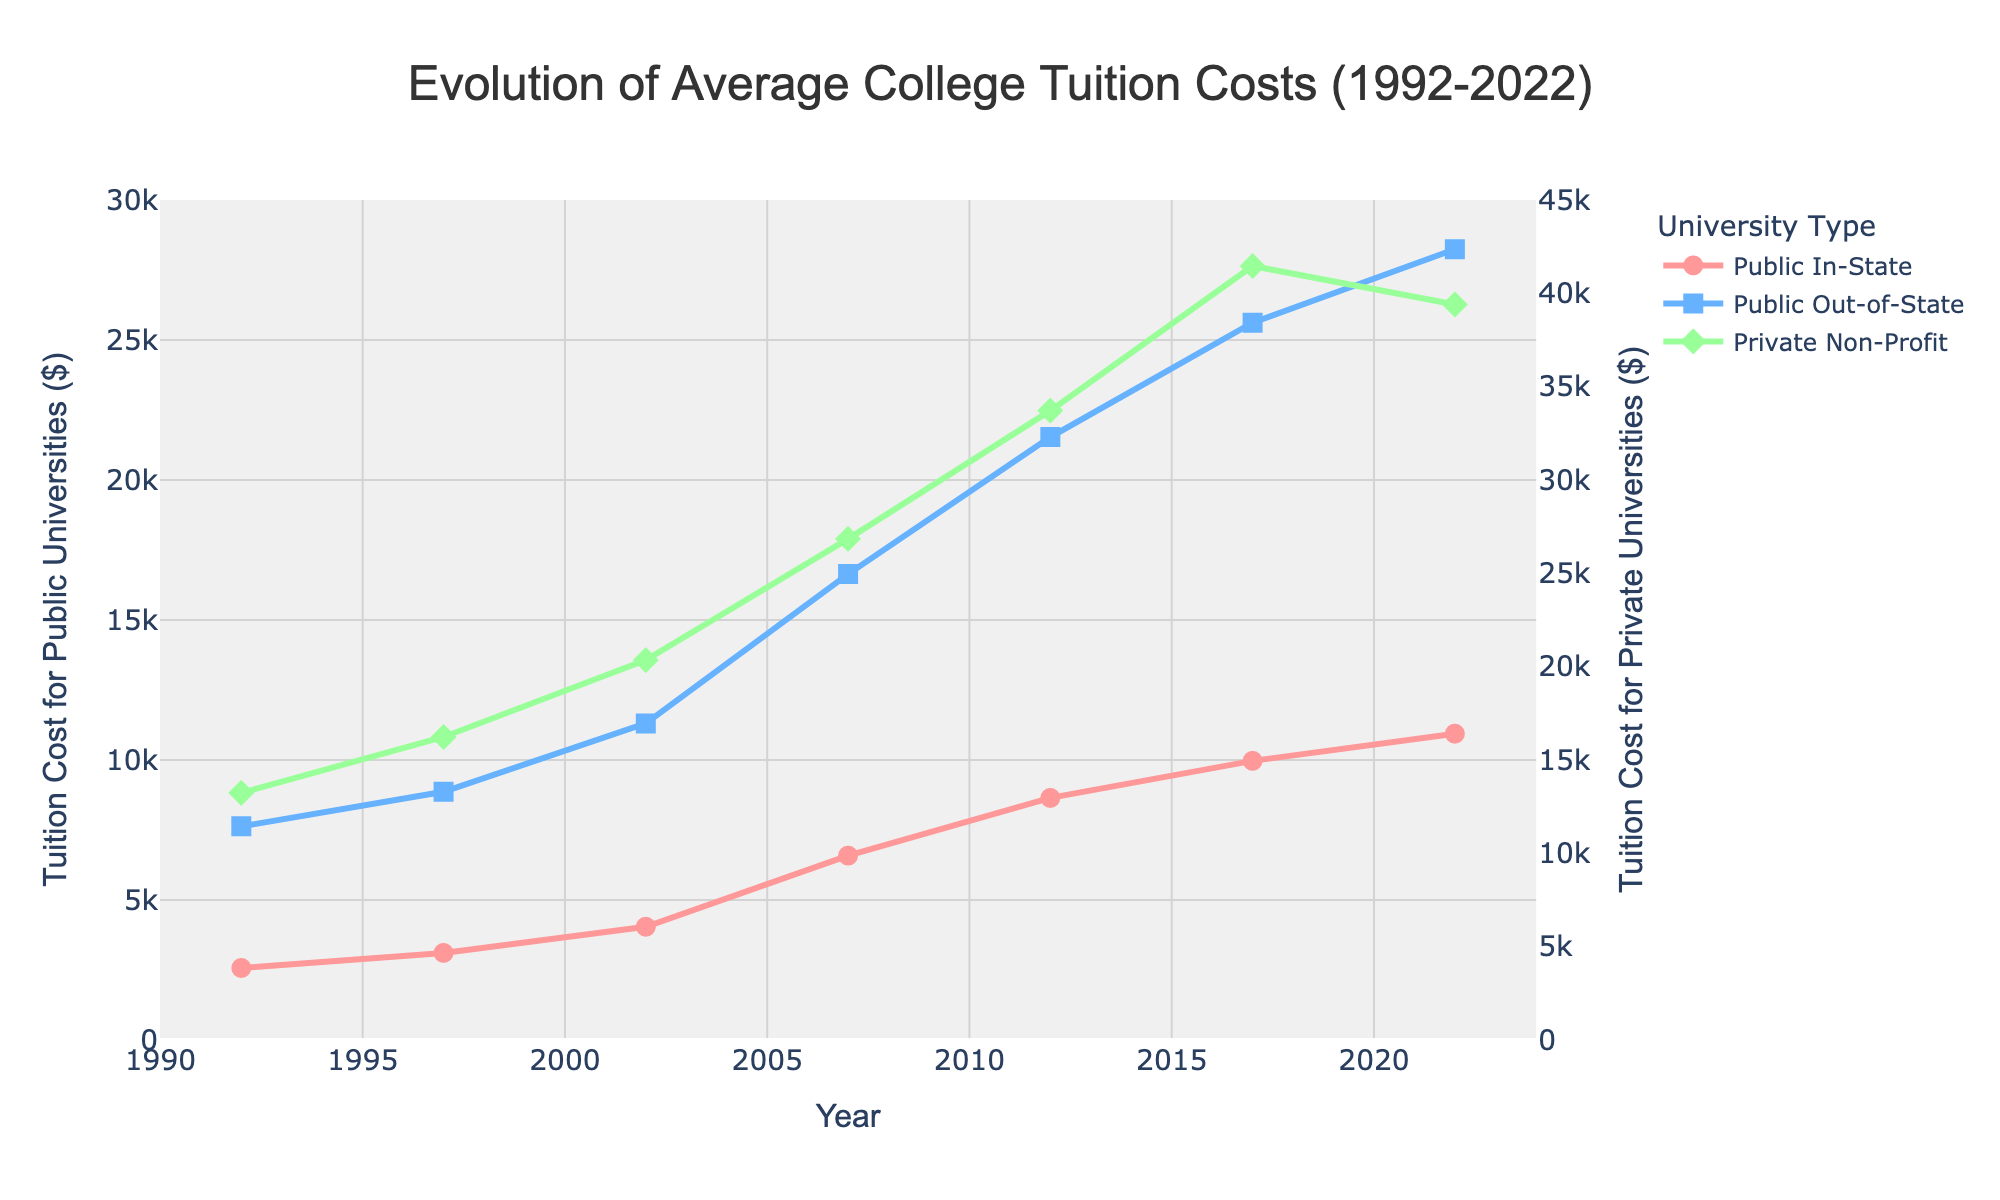what is the tuition cost trend for public in-state universities from 1992 to 2022? The line graph for the 'Public In-State' tuition costs shows a steady upward trend from 1992 to 2022, indicating an increase every year.
Answer: Upward trend which type of university had the highest tuition cost in 2022? The 'Private Non-Profit' line is the highest in 2022, indicating it had the highest tuition cost.
Answer: Private Non-Profit how much did public out-of-state tuition increase from 1992 to 2022? In 1992, the tuition for 'Public Out-of-State' was $7,630, and in 2022 it was $28,240. The increase is calculated as $28,240 - $7,630 = $20,610.
Answer: $20,610 what is the difference between public in-state and private non-profit tuition in 2017? The 'Public In-State' tuition in 2017 was $9,970, and the 'Private Non-Profit' tuition was $41,468. The difference is $41,468 - $9,970 = $31,498.
Answer: $31,498 during which year did public in-state tuition experience the largest increase? By analyzing the 'Public In-State' line, the largest increase appears between 2002 ($4,046) and 2007 ($6,585). The increase is $6,585 - $4,046 = $2,539.
Answer: 2002 to 2007 what is the visual difference between public out-of-state and private non-profit lines in terms of color and marker shape? The 'Public Out-of-State' line is blue with square markers, while the 'Private Non-Profit' line is green with diamond markers.
Answer: Blue with squares, Green with diamonds is there ever a year when public out-of-state tuition is higher than private non-profit tuition? By examining the graph lines, public out-of-state tuition is never higher than private non-profit tuition in any year displayed.
Answer: No what is the average tuition cost for private non-profit universities over the 30 years? Adding the tuition costs for 'Private Non-Profit' universities across all years (13237, 16233, 20352, 26845, 33716, 41468, 39400) and then dividing by the number of years (7): (13237 + 16233 + 20352 + 26845 + 33716 + 41468 + 39400) / 7. The total sum is 191251, so the average is 191251 / 7 = $27,322.
Answer: $27,322 in which year did public in-state tuition surpass $5,000? By examining the 'Public In-State' line, it first surpasses $5,000 in 2007 with a value of $6,585.
Answer: 2007 